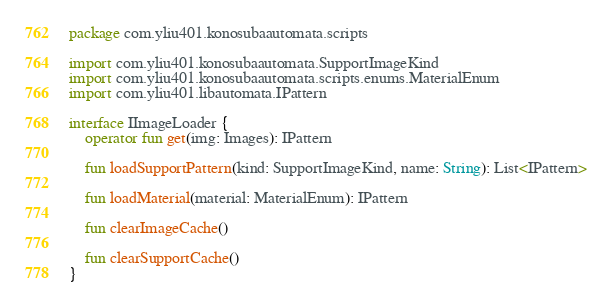<code> <loc_0><loc_0><loc_500><loc_500><_Kotlin_>package com.yliu401.konosubaautomata.scripts

import com.yliu401.konosubaautomata.SupportImageKind
import com.yliu401.konosubaautomata.scripts.enums.MaterialEnum
import com.yliu401.libautomata.IPattern

interface IImageLoader {
    operator fun get(img: Images): IPattern

    fun loadSupportPattern(kind: SupportImageKind, name: String): List<IPattern>

    fun loadMaterial(material: MaterialEnum): IPattern

    fun clearImageCache()

    fun clearSupportCache()
}</code> 